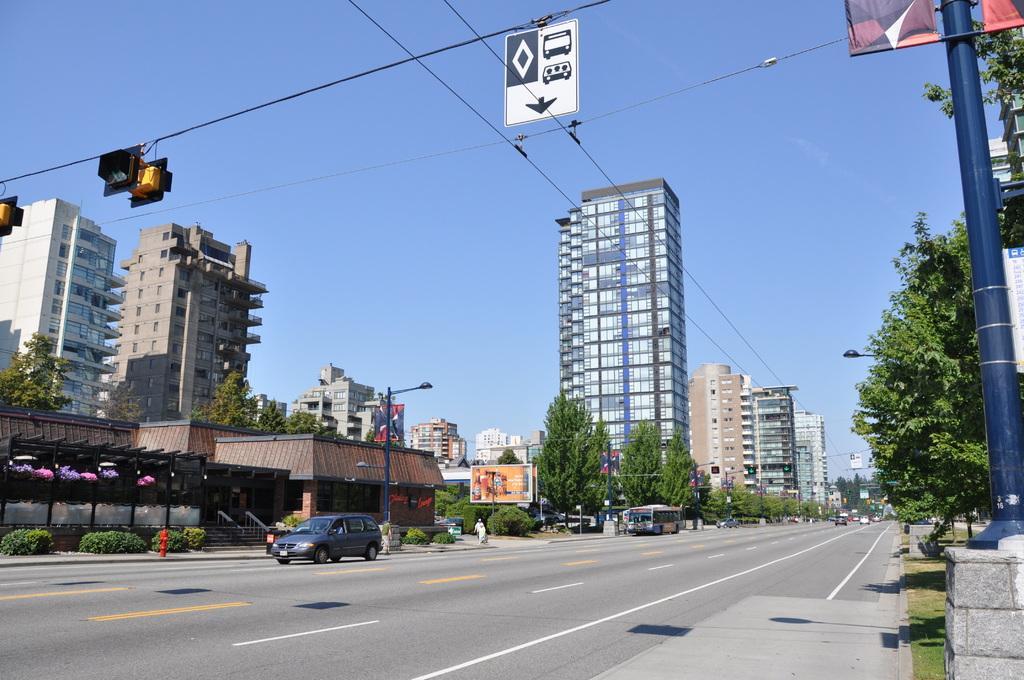How would you summarize this image in a sentence or two? This is the picture of a city. In this image there are buildings and trees and there are street lights and there are wires on the poles and there are vehicles on the road. At the back there is a fire hydrant and there is a person walking on the footpath and there is a hoarding and there is a stair case and there are hand rails. At the top there is sky. At the bottom there is a road and there is grass. 